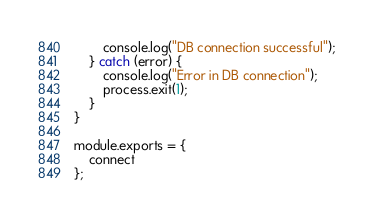<code> <loc_0><loc_0><loc_500><loc_500><_JavaScript_>        console.log("DB connection successful");
    } catch (error) {
        console.log("Error in DB connection");
        process.exit(1);
    }
}

module.exports = {
    connect
};</code> 